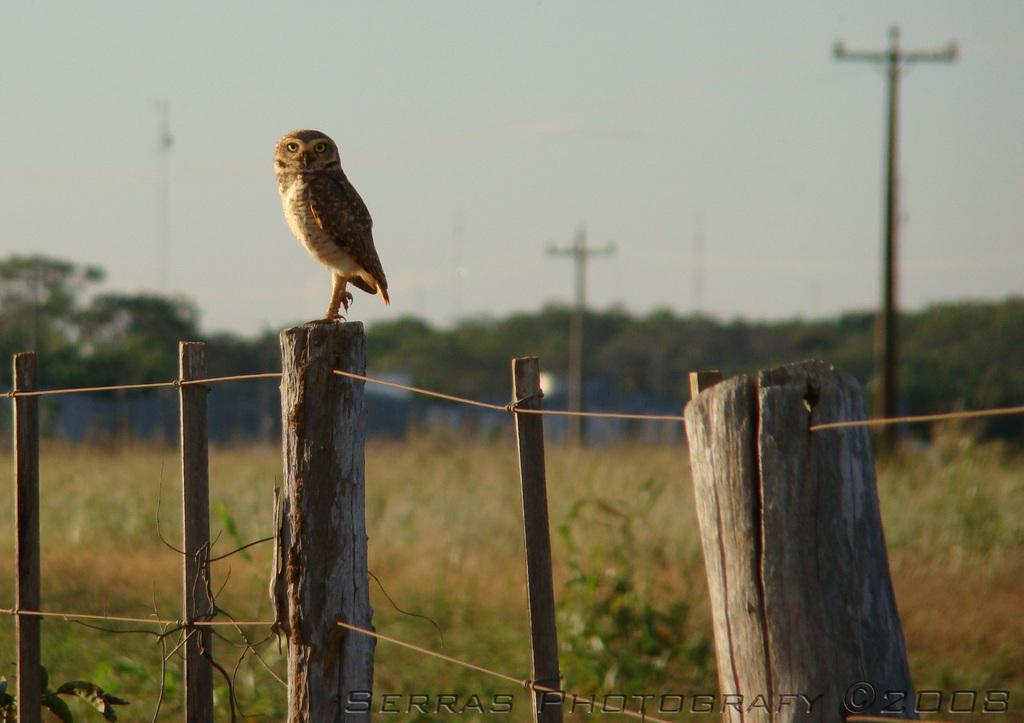What is the main subject of the image? There is a bird on a wooden log in the image. What type of natural environment is depicted in the image? There are trees visible in the image. What utility infrastructure can be seen in the image? Current poles are present in the image. What is visible in the background of the image? The sky is visible in the image. What type of barrier is present in the image? There is fencing in the image. What type of company is depicted in the image? There is no company present in the image; it features a bird on a wooden log, trees, current poles, the sky, and fencing. What type of emotion is the bird expressing in the image? The image does not depict the bird's emotions, so it cannot be determined from the image. 